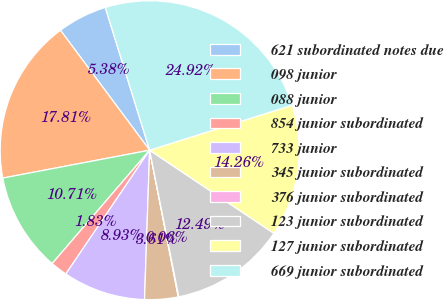<chart> <loc_0><loc_0><loc_500><loc_500><pie_chart><fcel>621 subordinated notes due<fcel>098 junior<fcel>088 junior<fcel>854 junior subordinated<fcel>733 junior<fcel>345 junior subordinated<fcel>376 junior subordinated<fcel>123 junior subordinated<fcel>127 junior subordinated<fcel>669 junior subordinated<nl><fcel>5.38%<fcel>17.81%<fcel>10.71%<fcel>1.83%<fcel>8.93%<fcel>3.61%<fcel>0.06%<fcel>12.49%<fcel>14.26%<fcel>24.92%<nl></chart> 